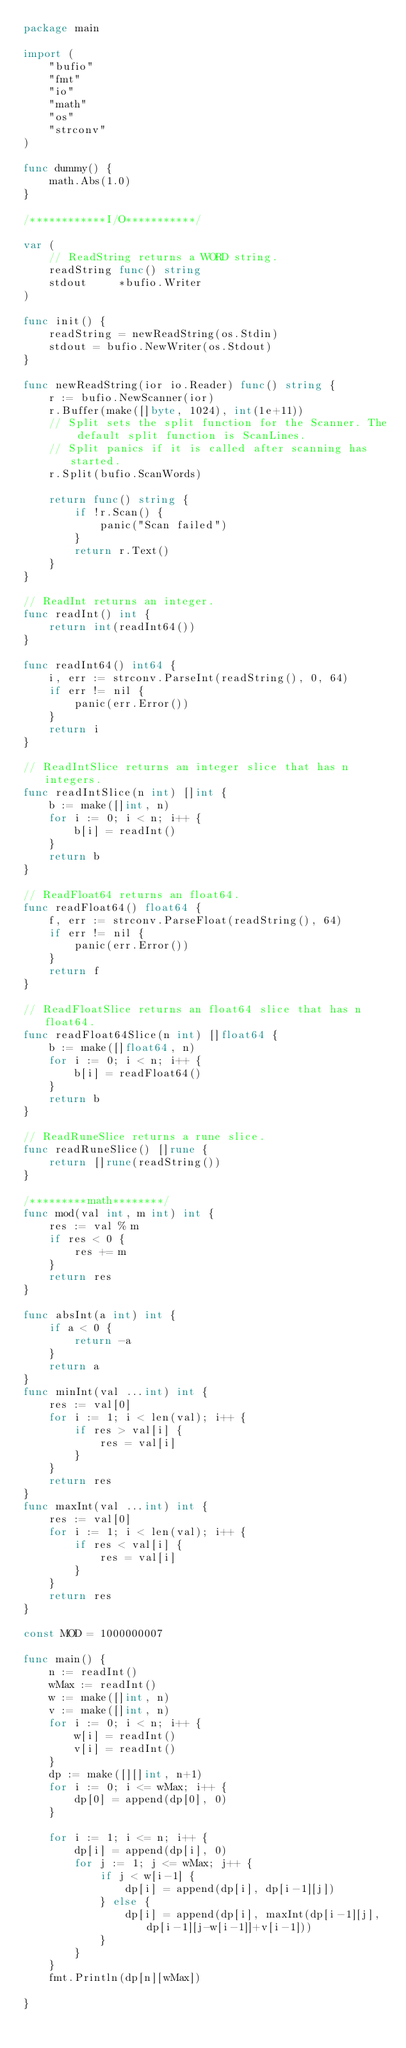Convert code to text. <code><loc_0><loc_0><loc_500><loc_500><_Go_>package main

import (
	"bufio"
	"fmt"
	"io"
	"math"
	"os"
	"strconv"
)

func dummy() {
	math.Abs(1.0)
}

/************I/O***********/

var (
	// ReadString returns a WORD string.
	readString func() string
	stdout     *bufio.Writer
)

func init() {
	readString = newReadString(os.Stdin)
	stdout = bufio.NewWriter(os.Stdout)
}

func newReadString(ior io.Reader) func() string {
	r := bufio.NewScanner(ior)
	r.Buffer(make([]byte, 1024), int(1e+11))
	// Split sets the split function for the Scanner. The default split function is ScanLines.
	// Split panics if it is called after scanning has started.
	r.Split(bufio.ScanWords)

	return func() string {
		if !r.Scan() {
			panic("Scan failed")
		}
		return r.Text()
	}
}

// ReadInt returns an integer.
func readInt() int {
	return int(readInt64())
}

func readInt64() int64 {
	i, err := strconv.ParseInt(readString(), 0, 64)
	if err != nil {
		panic(err.Error())
	}
	return i
}

// ReadIntSlice returns an integer slice that has n integers.
func readIntSlice(n int) []int {
	b := make([]int, n)
	for i := 0; i < n; i++ {
		b[i] = readInt()
	}
	return b
}

// ReadFloat64 returns an float64.
func readFloat64() float64 {
	f, err := strconv.ParseFloat(readString(), 64)
	if err != nil {
		panic(err.Error())
	}
	return f
}

// ReadFloatSlice returns an float64 slice that has n float64.
func readFloat64Slice(n int) []float64 {
	b := make([]float64, n)
	for i := 0; i < n; i++ {
		b[i] = readFloat64()
	}
	return b
}

// ReadRuneSlice returns a rune slice.
func readRuneSlice() []rune {
	return []rune(readString())
}

/*********math********/
func mod(val int, m int) int {
	res := val % m
	if res < 0 {
		res += m
	}
	return res
}

func absInt(a int) int {
	if a < 0 {
		return -a
	}
	return a
}
func minInt(val ...int) int {
	res := val[0]
	for i := 1; i < len(val); i++ {
		if res > val[i] {
			res = val[i]
		}
	}
	return res
}
func maxInt(val ...int) int {
	res := val[0]
	for i := 1; i < len(val); i++ {
		if res < val[i] {
			res = val[i]
		}
	}
	return res
}

const MOD = 1000000007

func main() {
	n := readInt()
	wMax := readInt()
	w := make([]int, n)
	v := make([]int, n)
	for i := 0; i < n; i++ {
		w[i] = readInt()
		v[i] = readInt()
	}
	dp := make([][]int, n+1)
	for i := 0; i <= wMax; i++ {
		dp[0] = append(dp[0], 0)
	}

	for i := 1; i <= n; i++ {
		dp[i] = append(dp[i], 0)
		for j := 1; j <= wMax; j++ {
			if j < w[i-1] {
				dp[i] = append(dp[i], dp[i-1][j])
			} else {
				dp[i] = append(dp[i], maxInt(dp[i-1][j], dp[i-1][j-w[i-1]]+v[i-1]))
			}
		}
	}
	fmt.Println(dp[n][wMax])

}
</code> 